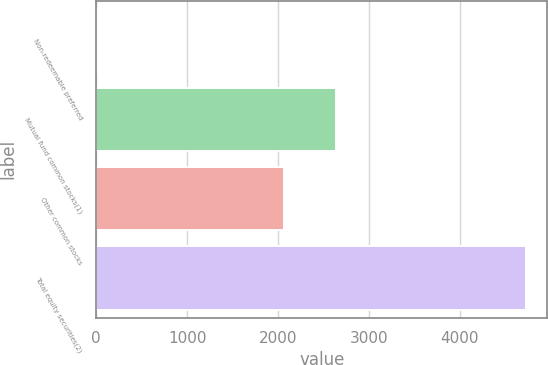Convert chart. <chart><loc_0><loc_0><loc_500><loc_500><bar_chart><fcel>Non-redeemable preferred<fcel>Mutual fund common stocks(1)<fcel>Other common stocks<fcel>Total equity securities(2)<nl><fcel>23<fcel>2638<fcel>2064<fcel>4725<nl></chart> 